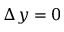Convert formula to latex. <formula><loc_0><loc_0><loc_500><loc_500>\Delta y = 0</formula> 